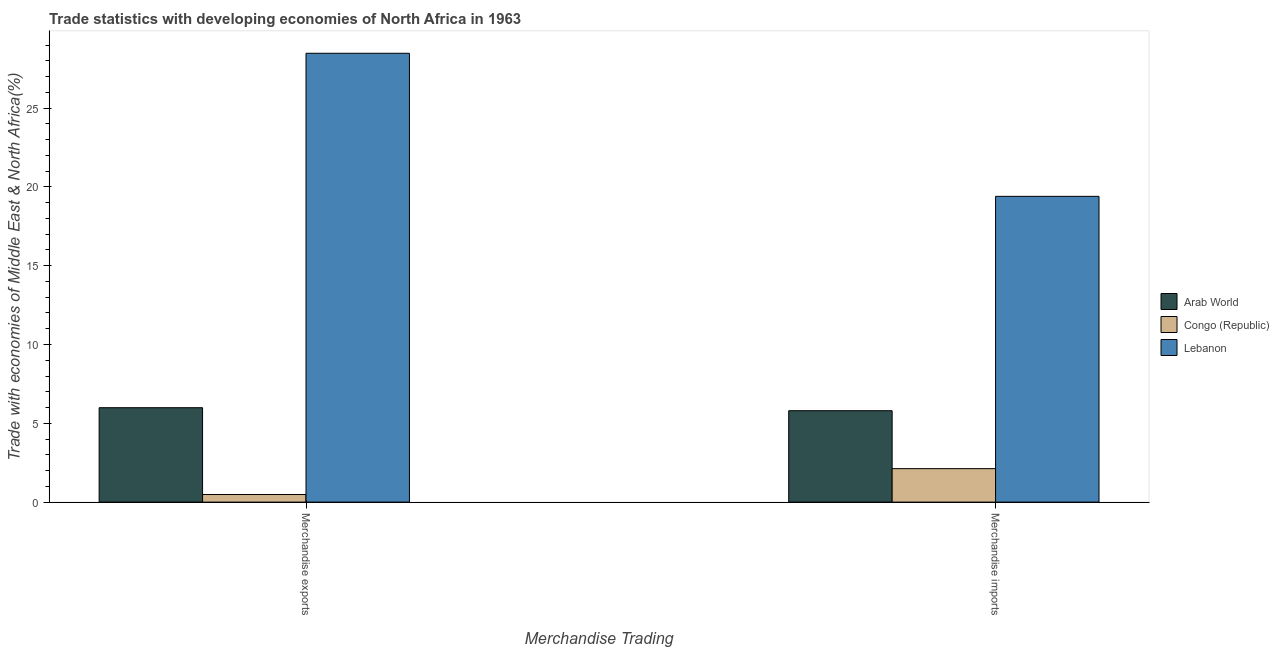How many groups of bars are there?
Your response must be concise. 2. Are the number of bars on each tick of the X-axis equal?
Provide a short and direct response. Yes. How many bars are there on the 2nd tick from the left?
Provide a short and direct response. 3. What is the label of the 1st group of bars from the left?
Provide a succinct answer. Merchandise exports. What is the merchandise exports in Arab World?
Your answer should be very brief. 5.99. Across all countries, what is the maximum merchandise exports?
Offer a very short reply. 28.48. Across all countries, what is the minimum merchandise imports?
Your answer should be very brief. 2.12. In which country was the merchandise exports maximum?
Provide a succinct answer. Lebanon. In which country was the merchandise exports minimum?
Give a very brief answer. Congo (Republic). What is the total merchandise exports in the graph?
Give a very brief answer. 34.95. What is the difference between the merchandise imports in Arab World and that in Lebanon?
Make the answer very short. -13.6. What is the difference between the merchandise imports in Congo (Republic) and the merchandise exports in Arab World?
Offer a terse response. -3.87. What is the average merchandise imports per country?
Provide a succinct answer. 9.11. What is the difference between the merchandise exports and merchandise imports in Arab World?
Give a very brief answer. 0.19. In how many countries, is the merchandise exports greater than 25 %?
Provide a short and direct response. 1. What is the ratio of the merchandise imports in Arab World to that in Lebanon?
Make the answer very short. 0.3. Is the merchandise imports in Arab World less than that in Congo (Republic)?
Ensure brevity in your answer.  No. What does the 3rd bar from the left in Merchandise imports represents?
Offer a very short reply. Lebanon. What does the 2nd bar from the right in Merchandise imports represents?
Your answer should be very brief. Congo (Republic). How many bars are there?
Your response must be concise. 6. What is the difference between two consecutive major ticks on the Y-axis?
Your answer should be compact. 5. Are the values on the major ticks of Y-axis written in scientific E-notation?
Your response must be concise. No. Does the graph contain grids?
Ensure brevity in your answer.  No. Where does the legend appear in the graph?
Make the answer very short. Center right. How many legend labels are there?
Provide a succinct answer. 3. How are the legend labels stacked?
Offer a terse response. Vertical. What is the title of the graph?
Ensure brevity in your answer.  Trade statistics with developing economies of North Africa in 1963. Does "Gabon" appear as one of the legend labels in the graph?
Make the answer very short. No. What is the label or title of the X-axis?
Your answer should be compact. Merchandise Trading. What is the label or title of the Y-axis?
Offer a terse response. Trade with economies of Middle East & North Africa(%). What is the Trade with economies of Middle East & North Africa(%) of Arab World in Merchandise exports?
Your answer should be very brief. 5.99. What is the Trade with economies of Middle East & North Africa(%) in Congo (Republic) in Merchandise exports?
Ensure brevity in your answer.  0.48. What is the Trade with economies of Middle East & North Africa(%) of Lebanon in Merchandise exports?
Keep it short and to the point. 28.48. What is the Trade with economies of Middle East & North Africa(%) of Arab World in Merchandise imports?
Provide a succinct answer. 5.8. What is the Trade with economies of Middle East & North Africa(%) of Congo (Republic) in Merchandise imports?
Keep it short and to the point. 2.12. What is the Trade with economies of Middle East & North Africa(%) of Lebanon in Merchandise imports?
Ensure brevity in your answer.  19.4. Across all Merchandise Trading, what is the maximum Trade with economies of Middle East & North Africa(%) of Arab World?
Your response must be concise. 5.99. Across all Merchandise Trading, what is the maximum Trade with economies of Middle East & North Africa(%) of Congo (Republic)?
Keep it short and to the point. 2.12. Across all Merchandise Trading, what is the maximum Trade with economies of Middle East & North Africa(%) in Lebanon?
Give a very brief answer. 28.48. Across all Merchandise Trading, what is the minimum Trade with economies of Middle East & North Africa(%) in Arab World?
Give a very brief answer. 5.8. Across all Merchandise Trading, what is the minimum Trade with economies of Middle East & North Africa(%) in Congo (Republic)?
Keep it short and to the point. 0.48. Across all Merchandise Trading, what is the minimum Trade with economies of Middle East & North Africa(%) of Lebanon?
Your response must be concise. 19.4. What is the total Trade with economies of Middle East & North Africa(%) of Arab World in the graph?
Provide a succinct answer. 11.79. What is the total Trade with economies of Middle East & North Africa(%) in Congo (Republic) in the graph?
Make the answer very short. 2.61. What is the total Trade with economies of Middle East & North Africa(%) in Lebanon in the graph?
Offer a terse response. 47.88. What is the difference between the Trade with economies of Middle East & North Africa(%) in Arab World in Merchandise exports and that in Merchandise imports?
Give a very brief answer. 0.19. What is the difference between the Trade with economies of Middle East & North Africa(%) of Congo (Republic) in Merchandise exports and that in Merchandise imports?
Offer a very short reply. -1.64. What is the difference between the Trade with economies of Middle East & North Africa(%) in Lebanon in Merchandise exports and that in Merchandise imports?
Offer a very short reply. 9.08. What is the difference between the Trade with economies of Middle East & North Africa(%) of Arab World in Merchandise exports and the Trade with economies of Middle East & North Africa(%) of Congo (Republic) in Merchandise imports?
Your answer should be compact. 3.87. What is the difference between the Trade with economies of Middle East & North Africa(%) in Arab World in Merchandise exports and the Trade with economies of Middle East & North Africa(%) in Lebanon in Merchandise imports?
Offer a very short reply. -13.41. What is the difference between the Trade with economies of Middle East & North Africa(%) in Congo (Republic) in Merchandise exports and the Trade with economies of Middle East & North Africa(%) in Lebanon in Merchandise imports?
Your answer should be very brief. -18.92. What is the average Trade with economies of Middle East & North Africa(%) in Arab World per Merchandise Trading?
Your response must be concise. 5.89. What is the average Trade with economies of Middle East & North Africa(%) in Congo (Republic) per Merchandise Trading?
Provide a short and direct response. 1.3. What is the average Trade with economies of Middle East & North Africa(%) in Lebanon per Merchandise Trading?
Your answer should be compact. 23.94. What is the difference between the Trade with economies of Middle East & North Africa(%) in Arab World and Trade with economies of Middle East & North Africa(%) in Congo (Republic) in Merchandise exports?
Provide a short and direct response. 5.51. What is the difference between the Trade with economies of Middle East & North Africa(%) of Arab World and Trade with economies of Middle East & North Africa(%) of Lebanon in Merchandise exports?
Your response must be concise. -22.49. What is the difference between the Trade with economies of Middle East & North Africa(%) in Congo (Republic) and Trade with economies of Middle East & North Africa(%) in Lebanon in Merchandise exports?
Give a very brief answer. -27.99. What is the difference between the Trade with economies of Middle East & North Africa(%) of Arab World and Trade with economies of Middle East & North Africa(%) of Congo (Republic) in Merchandise imports?
Make the answer very short. 3.68. What is the difference between the Trade with economies of Middle East & North Africa(%) of Arab World and Trade with economies of Middle East & North Africa(%) of Lebanon in Merchandise imports?
Your answer should be very brief. -13.6. What is the difference between the Trade with economies of Middle East & North Africa(%) of Congo (Republic) and Trade with economies of Middle East & North Africa(%) of Lebanon in Merchandise imports?
Provide a short and direct response. -17.27. What is the ratio of the Trade with economies of Middle East & North Africa(%) of Arab World in Merchandise exports to that in Merchandise imports?
Your answer should be compact. 1.03. What is the ratio of the Trade with economies of Middle East & North Africa(%) in Congo (Republic) in Merchandise exports to that in Merchandise imports?
Your answer should be very brief. 0.23. What is the ratio of the Trade with economies of Middle East & North Africa(%) of Lebanon in Merchandise exports to that in Merchandise imports?
Provide a short and direct response. 1.47. What is the difference between the highest and the second highest Trade with economies of Middle East & North Africa(%) of Arab World?
Offer a terse response. 0.19. What is the difference between the highest and the second highest Trade with economies of Middle East & North Africa(%) of Congo (Republic)?
Give a very brief answer. 1.64. What is the difference between the highest and the second highest Trade with economies of Middle East & North Africa(%) of Lebanon?
Your response must be concise. 9.08. What is the difference between the highest and the lowest Trade with economies of Middle East & North Africa(%) of Arab World?
Keep it short and to the point. 0.19. What is the difference between the highest and the lowest Trade with economies of Middle East & North Africa(%) of Congo (Republic)?
Keep it short and to the point. 1.64. What is the difference between the highest and the lowest Trade with economies of Middle East & North Africa(%) in Lebanon?
Your answer should be compact. 9.08. 